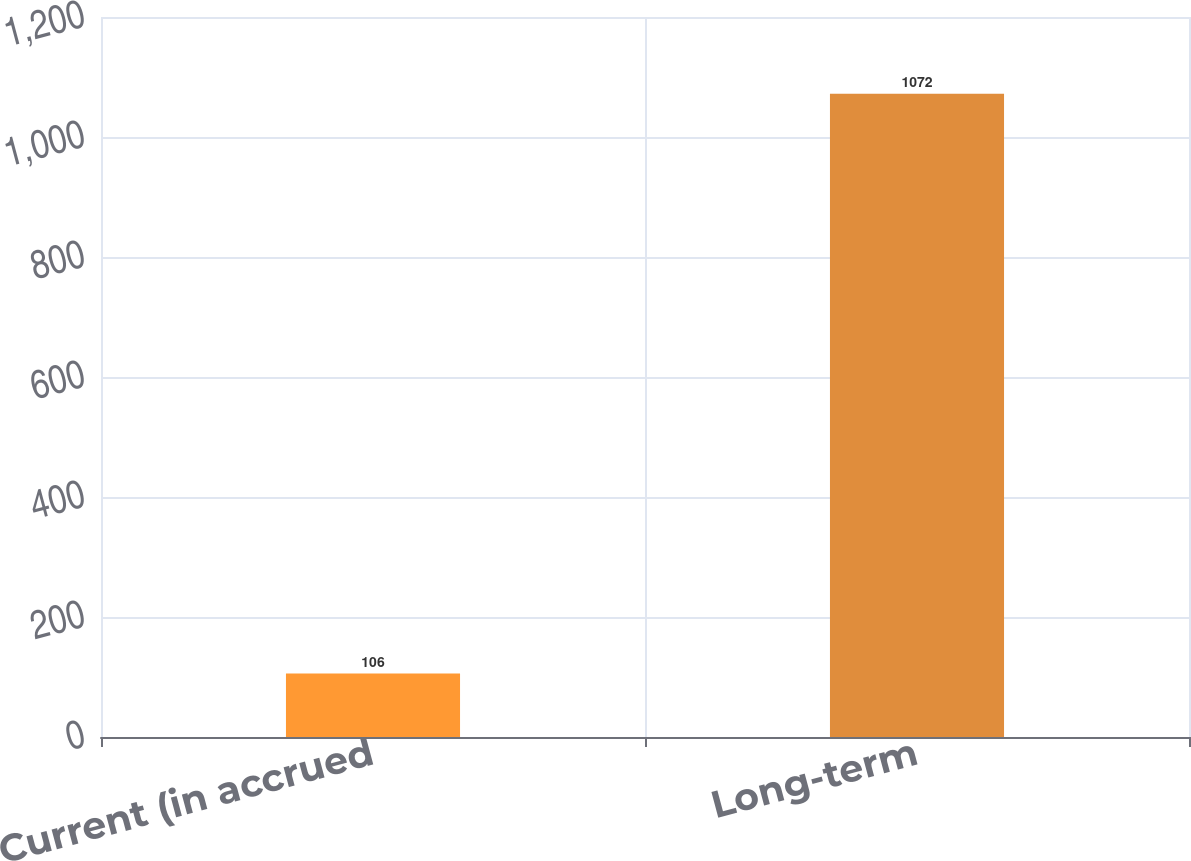Convert chart. <chart><loc_0><loc_0><loc_500><loc_500><bar_chart><fcel>Current (in accrued<fcel>Long-term<nl><fcel>106<fcel>1072<nl></chart> 